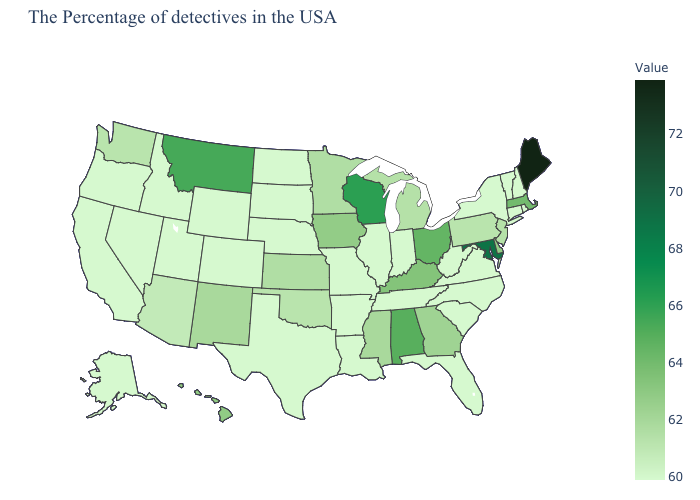Among the states that border Missouri , which have the lowest value?
Short answer required. Tennessee, Illinois, Arkansas, Nebraska. Which states have the highest value in the USA?
Keep it brief. Maine. Among the states that border Texas , does Oklahoma have the highest value?
Keep it brief. No. Which states have the lowest value in the South?
Answer briefly. Virginia, North Carolina, South Carolina, West Virginia, Florida, Tennessee, Louisiana, Arkansas, Texas. Which states hav the highest value in the Northeast?
Keep it brief. Maine. Does Wisconsin have the highest value in the MidWest?
Be succinct. Yes. 